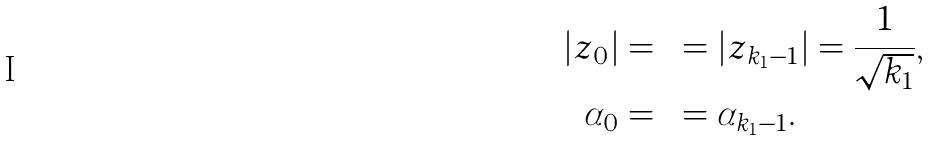<formula> <loc_0><loc_0><loc_500><loc_500>| z _ { 0 } | & = \cdots = | z _ { k _ { 1 } - 1 } | = \frac { 1 } { \sqrt { k _ { 1 } } } , \\ \alpha _ { 0 } & = \cdots = \alpha _ { k _ { 1 } - 1 } .</formula> 